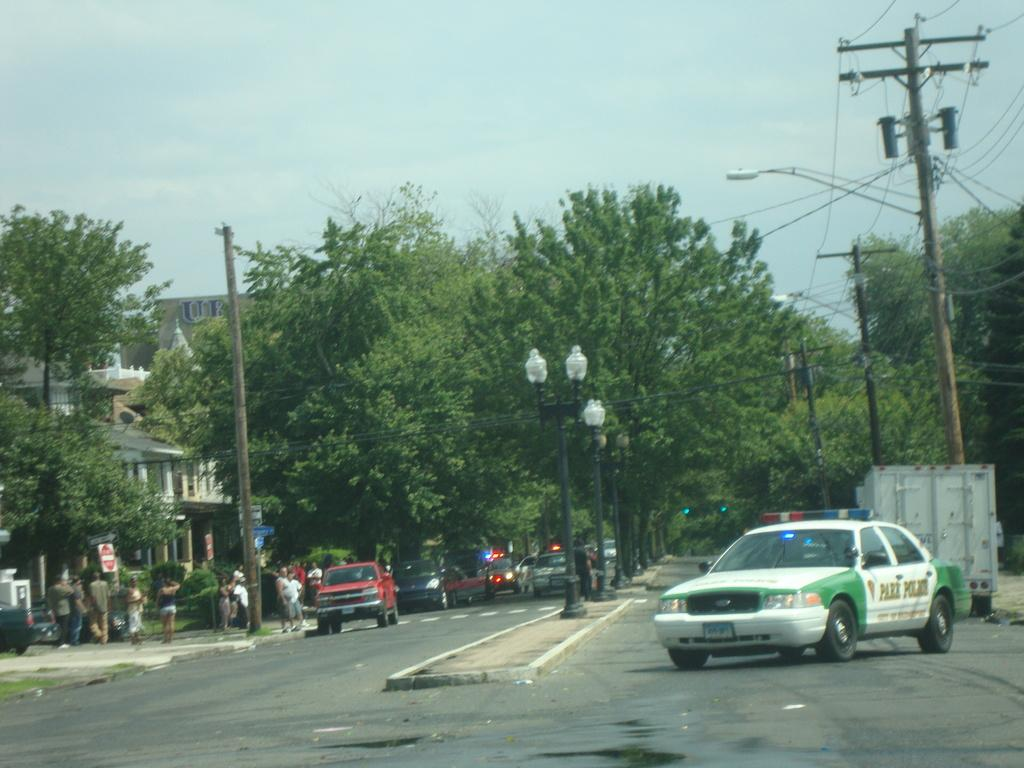What type of vehicles can be seen on the road in the image? There are cars on the road in the image. What structures are present in the image besides the cars? There are poles, trees, wires, signboards, buildings, and people on a footpath in the image. What is visible in the background of the image? The sky is visible in the background of the image. What type of fear can be seen on the faces of the dogs in the image? There are no dogs present in the image, so it is not possible to determine if they are experiencing any fear. 